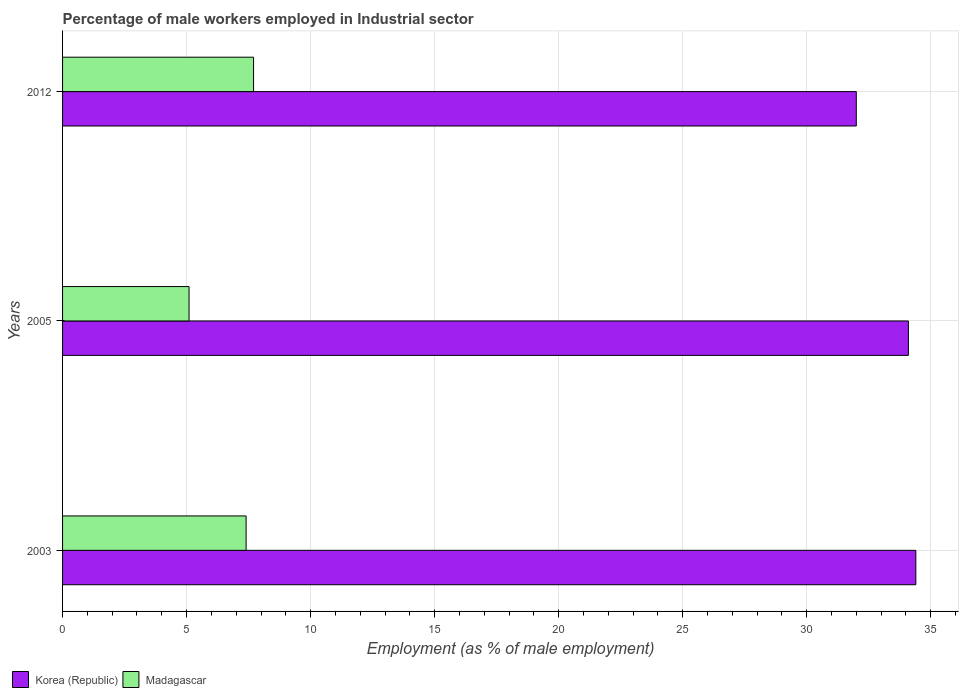How many different coloured bars are there?
Your response must be concise. 2. How many groups of bars are there?
Offer a terse response. 3. Are the number of bars per tick equal to the number of legend labels?
Provide a short and direct response. Yes. How many bars are there on the 2nd tick from the top?
Provide a short and direct response. 2. How many bars are there on the 1st tick from the bottom?
Your answer should be compact. 2. What is the percentage of male workers employed in Industrial sector in Madagascar in 2003?
Provide a succinct answer. 7.4. Across all years, what is the maximum percentage of male workers employed in Industrial sector in Korea (Republic)?
Provide a short and direct response. 34.4. Across all years, what is the minimum percentage of male workers employed in Industrial sector in Madagascar?
Ensure brevity in your answer.  5.1. In which year was the percentage of male workers employed in Industrial sector in Korea (Republic) maximum?
Give a very brief answer. 2003. What is the total percentage of male workers employed in Industrial sector in Madagascar in the graph?
Offer a terse response. 20.2. What is the difference between the percentage of male workers employed in Industrial sector in Korea (Republic) in 2003 and that in 2012?
Provide a succinct answer. 2.4. What is the difference between the percentage of male workers employed in Industrial sector in Korea (Republic) in 2005 and the percentage of male workers employed in Industrial sector in Madagascar in 2012?
Your answer should be compact. 26.4. What is the average percentage of male workers employed in Industrial sector in Madagascar per year?
Offer a very short reply. 6.73. In the year 2012, what is the difference between the percentage of male workers employed in Industrial sector in Korea (Republic) and percentage of male workers employed in Industrial sector in Madagascar?
Provide a succinct answer. 24.3. In how many years, is the percentage of male workers employed in Industrial sector in Korea (Republic) greater than 4 %?
Offer a terse response. 3. What is the ratio of the percentage of male workers employed in Industrial sector in Madagascar in 2005 to that in 2012?
Your answer should be compact. 0.66. Is the percentage of male workers employed in Industrial sector in Madagascar in 2003 less than that in 2005?
Ensure brevity in your answer.  No. Is the difference between the percentage of male workers employed in Industrial sector in Korea (Republic) in 2003 and 2012 greater than the difference between the percentage of male workers employed in Industrial sector in Madagascar in 2003 and 2012?
Offer a terse response. Yes. What is the difference between the highest and the second highest percentage of male workers employed in Industrial sector in Korea (Republic)?
Keep it short and to the point. 0.3. What is the difference between the highest and the lowest percentage of male workers employed in Industrial sector in Korea (Republic)?
Offer a very short reply. 2.4. In how many years, is the percentage of male workers employed in Industrial sector in Korea (Republic) greater than the average percentage of male workers employed in Industrial sector in Korea (Republic) taken over all years?
Give a very brief answer. 2. Is the sum of the percentage of male workers employed in Industrial sector in Korea (Republic) in 2003 and 2005 greater than the maximum percentage of male workers employed in Industrial sector in Madagascar across all years?
Provide a succinct answer. Yes. What does the 2nd bar from the top in 2003 represents?
Offer a terse response. Korea (Republic). What does the 2nd bar from the bottom in 2003 represents?
Make the answer very short. Madagascar. How many bars are there?
Your answer should be compact. 6. Are all the bars in the graph horizontal?
Provide a succinct answer. Yes. How many years are there in the graph?
Offer a very short reply. 3. What is the difference between two consecutive major ticks on the X-axis?
Your answer should be very brief. 5. Are the values on the major ticks of X-axis written in scientific E-notation?
Ensure brevity in your answer.  No. Does the graph contain any zero values?
Make the answer very short. No. Does the graph contain grids?
Make the answer very short. Yes. Where does the legend appear in the graph?
Make the answer very short. Bottom left. What is the title of the graph?
Keep it short and to the point. Percentage of male workers employed in Industrial sector. What is the label or title of the X-axis?
Your response must be concise. Employment (as % of male employment). What is the Employment (as % of male employment) in Korea (Republic) in 2003?
Your answer should be very brief. 34.4. What is the Employment (as % of male employment) of Madagascar in 2003?
Your answer should be very brief. 7.4. What is the Employment (as % of male employment) of Korea (Republic) in 2005?
Provide a succinct answer. 34.1. What is the Employment (as % of male employment) of Madagascar in 2005?
Give a very brief answer. 5.1. What is the Employment (as % of male employment) in Korea (Republic) in 2012?
Provide a succinct answer. 32. What is the Employment (as % of male employment) of Madagascar in 2012?
Your response must be concise. 7.7. Across all years, what is the maximum Employment (as % of male employment) of Korea (Republic)?
Offer a terse response. 34.4. Across all years, what is the maximum Employment (as % of male employment) of Madagascar?
Your answer should be compact. 7.7. Across all years, what is the minimum Employment (as % of male employment) in Korea (Republic)?
Your response must be concise. 32. Across all years, what is the minimum Employment (as % of male employment) of Madagascar?
Provide a succinct answer. 5.1. What is the total Employment (as % of male employment) in Korea (Republic) in the graph?
Offer a terse response. 100.5. What is the total Employment (as % of male employment) in Madagascar in the graph?
Your answer should be compact. 20.2. What is the difference between the Employment (as % of male employment) of Korea (Republic) in 2003 and that in 2005?
Provide a succinct answer. 0.3. What is the difference between the Employment (as % of male employment) of Madagascar in 2003 and that in 2005?
Offer a terse response. 2.3. What is the difference between the Employment (as % of male employment) of Korea (Republic) in 2003 and that in 2012?
Make the answer very short. 2.4. What is the difference between the Employment (as % of male employment) of Korea (Republic) in 2005 and that in 2012?
Give a very brief answer. 2.1. What is the difference between the Employment (as % of male employment) of Madagascar in 2005 and that in 2012?
Ensure brevity in your answer.  -2.6. What is the difference between the Employment (as % of male employment) in Korea (Republic) in 2003 and the Employment (as % of male employment) in Madagascar in 2005?
Keep it short and to the point. 29.3. What is the difference between the Employment (as % of male employment) of Korea (Republic) in 2003 and the Employment (as % of male employment) of Madagascar in 2012?
Your response must be concise. 26.7. What is the difference between the Employment (as % of male employment) in Korea (Republic) in 2005 and the Employment (as % of male employment) in Madagascar in 2012?
Offer a very short reply. 26.4. What is the average Employment (as % of male employment) of Korea (Republic) per year?
Your response must be concise. 33.5. What is the average Employment (as % of male employment) in Madagascar per year?
Offer a terse response. 6.73. In the year 2012, what is the difference between the Employment (as % of male employment) in Korea (Republic) and Employment (as % of male employment) in Madagascar?
Ensure brevity in your answer.  24.3. What is the ratio of the Employment (as % of male employment) in Korea (Republic) in 2003 to that in 2005?
Your answer should be compact. 1.01. What is the ratio of the Employment (as % of male employment) of Madagascar in 2003 to that in 2005?
Provide a short and direct response. 1.45. What is the ratio of the Employment (as % of male employment) in Korea (Republic) in 2003 to that in 2012?
Keep it short and to the point. 1.07. What is the ratio of the Employment (as % of male employment) of Korea (Republic) in 2005 to that in 2012?
Your answer should be very brief. 1.07. What is the ratio of the Employment (as % of male employment) in Madagascar in 2005 to that in 2012?
Your answer should be compact. 0.66. What is the difference between the highest and the second highest Employment (as % of male employment) of Madagascar?
Give a very brief answer. 0.3. What is the difference between the highest and the lowest Employment (as % of male employment) in Korea (Republic)?
Your response must be concise. 2.4. 